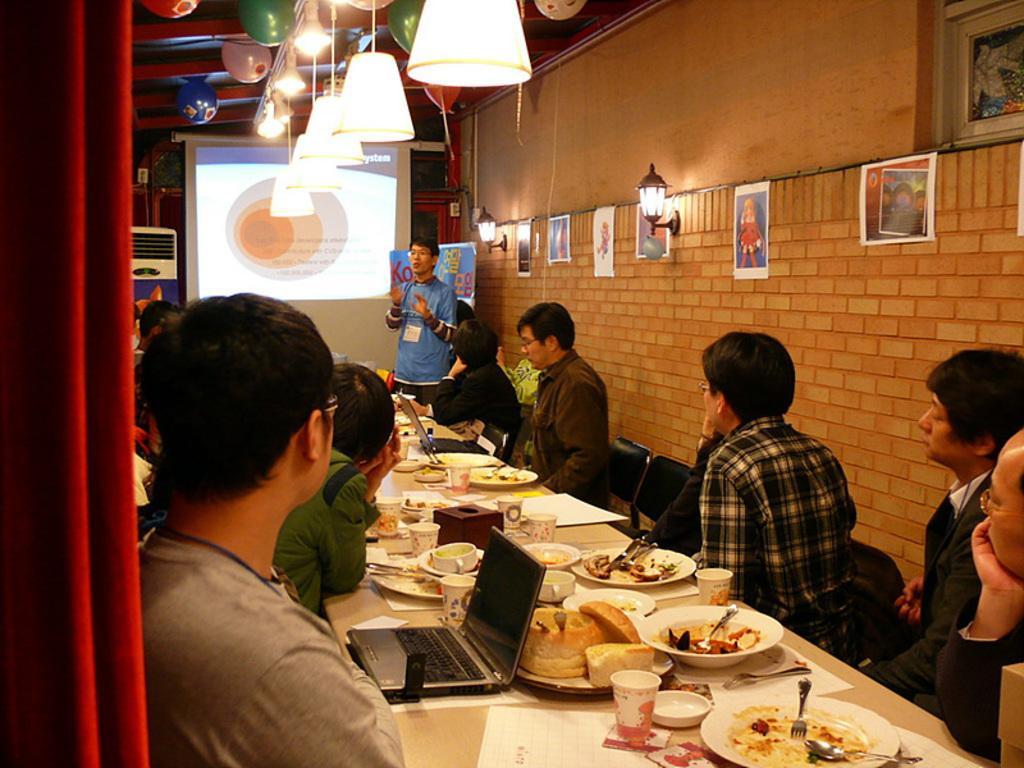In one or two sentences, can you explain what this image depicts? On the left side, there are persons in different color dresses in front of the tables on which there are food items, glasses and other objects and there is a red color curtain. On the right side, there are persons sitting on chairs. Above them, there are lights and balloons attached to the roof. In the background, there is a person standing and speaking, there are posters and lights attached to the wall, there is a screen and there are other objects. 